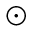Convert formula to latex. <formula><loc_0><loc_0><loc_500><loc_500>\odot</formula> 